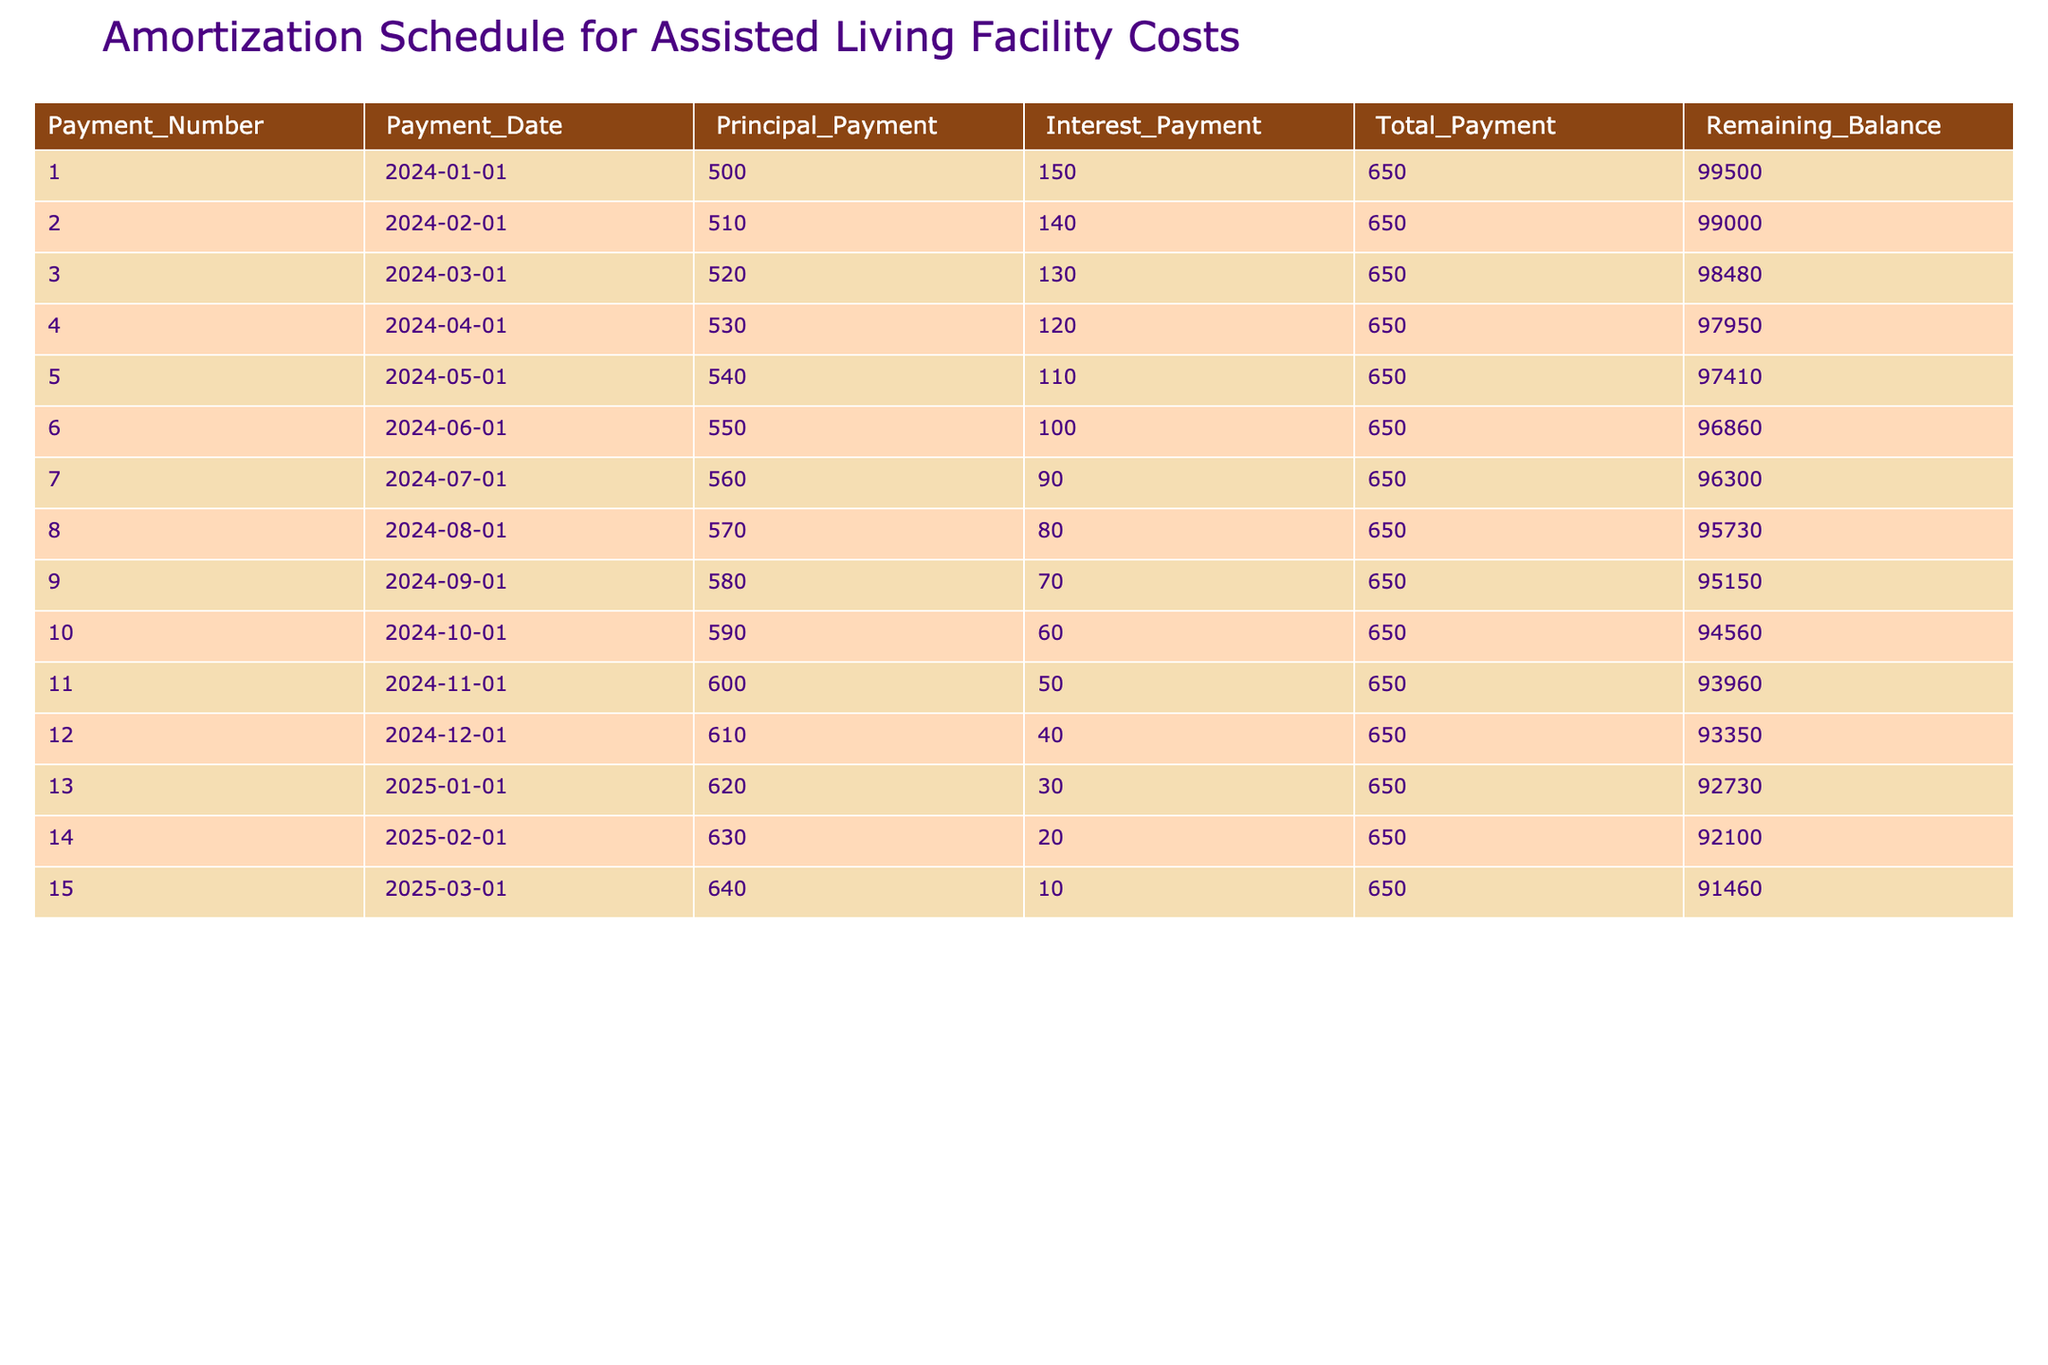What is the total payment for the first month? The total payment for the first month is listed in the table under "Total_Payment" for Payment_Number 1. It is directly shown as 650.
Answer: 650 How much of the payment in the sixth month goes towards the principal? The principal payment for the sixth month is shown under the "Principal_Payment" column for Payment_Number 6. It is 550.
Answer: 550 What is the remaining balance after the tenth payment? Looking at the remaining balance in the "Remaining_Balance" column for Payment_Number 10, the balance is found to be 94560.
Answer: 94560 Is the interest payment decreasing with each subsequent month? By reviewing the "Interest_Payment" column, it can be observed that the interest payments decrease every month, starting from 150 in the first month down to 60 in the tenth month. Thus, the statement is true.
Answer: Yes What is the average principal payment made over the first five months? To find the average principal payment for the first five months, first sum the principal payments: 500 + 510 + 520 + 530 + 540 = 2600. Then divide this by the number of payments, which is 5. The result is 2600 / 5 = 520.
Answer: 520 If a total of 650 is paid each month, how much will be paid in total over the first 12 months? The total payment can be calculated by multiplying the monthly payment of 650 by the total number of months, which is 12. Therefore, 650 * 12 = 7800.
Answer: 7800 What is the difference in principal payment from the first month to the last month outlined in the table? The principal payment for the first month is 500 and for the last month listed (Payment_Number 15) it is 640. The difference can be calculated as 640 - 500 = 140.
Answer: 140 In which month does the remaining balance fall below 93000? Observing the "Remaining_Balance" column, the balance first goes below 93000 after the 12th payment, which has a remaining balance of 93350, and ends with 92730 after the 13th payment. This indicates the change occurs in the 13th month.
Answer: 13th month What is the total interest paid in the first three payments? The interest payments for the first three payments are 150, 140, and 130. These can be summed as 150 + 140 + 130 = 420. Therefore, the total interest paid in that period is 420.
Answer: 420 